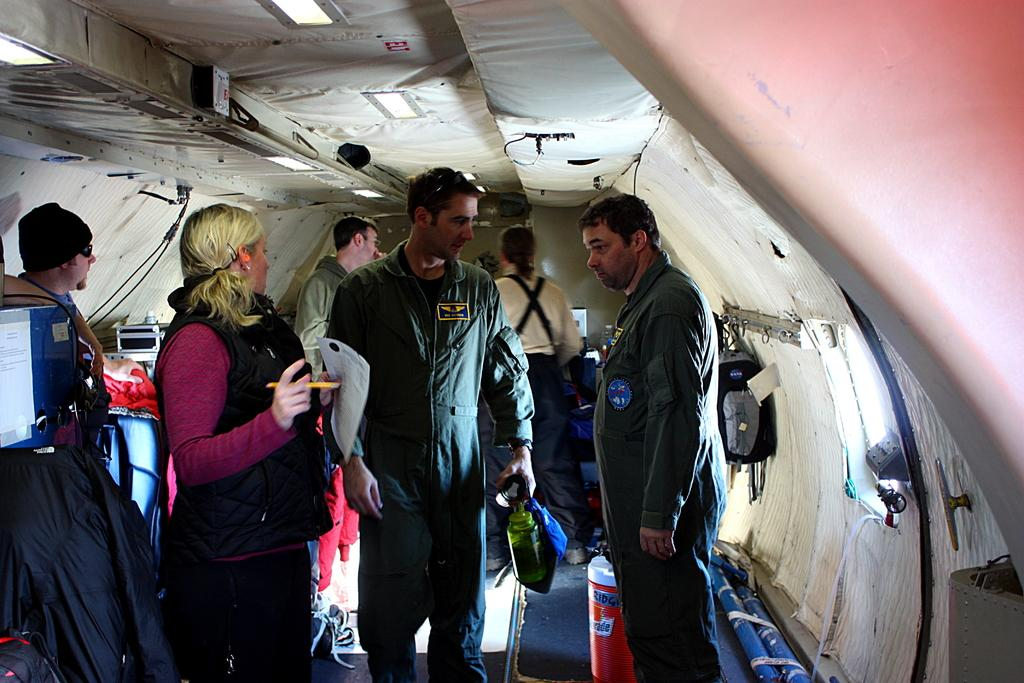What is the main setting of the image? There are people inside a tent in the image. What is the woman holding in the image? The woman is holding a paper and pencil. What is the man holding in the image? The man is holding a bottle. Can you describe any additional items in the image? There is a backpack hanged on a hanger in the image. What flavor of coffee is the woman drinking in the image? There is no coffee or any indication of a beverage in the image. 